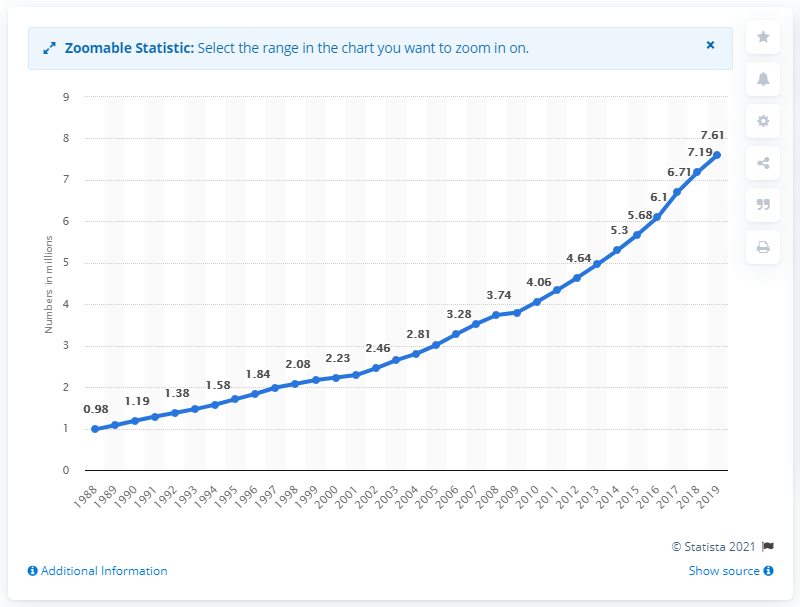Give some essential details in this illustration. In 2019, a total of 7,61,323 two-wheelers were registered in Delhi. 